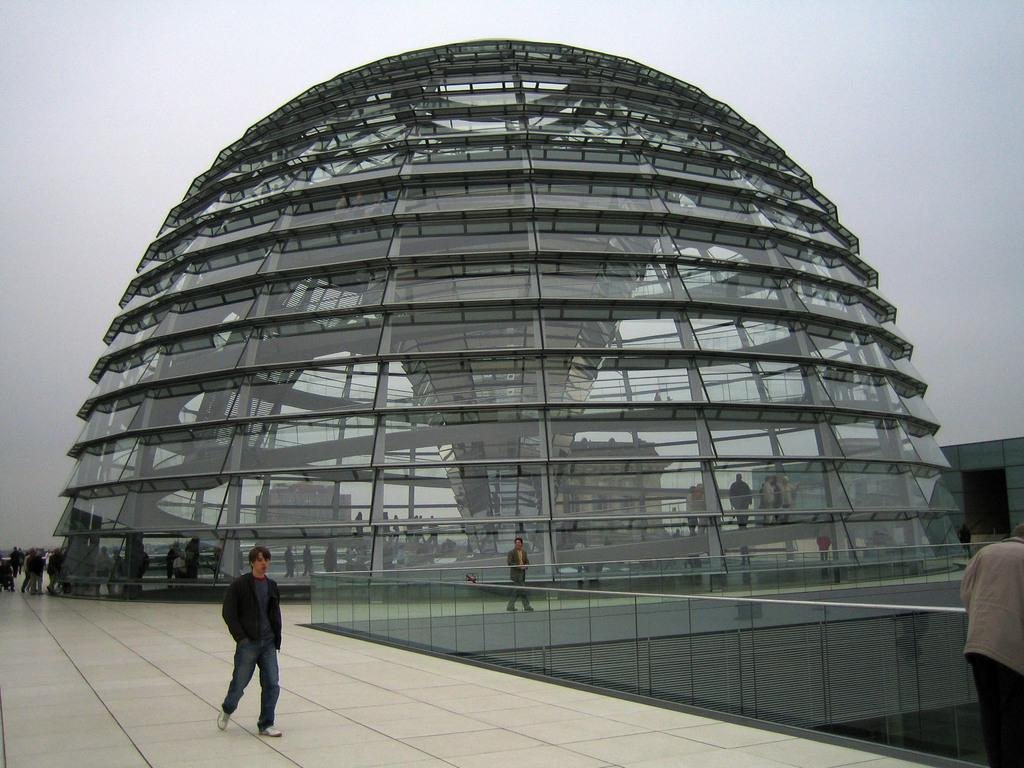What is the person on the right side of the image doing? The person is holding the railing on the right side of the image. What are the people in the image doing? There are people walking on the floor in the image. What can be seen in the background of the image? There are buildings and the sky visible in the background of the image. What type of bomb is being detonated in the image? There is no bomb present in the image; it features a person holding a railing and people walking on the floor. What thought is the person holding the railing having in the image? The image does not provide any information about the person's thoughts, so it cannot be determined from the image. 